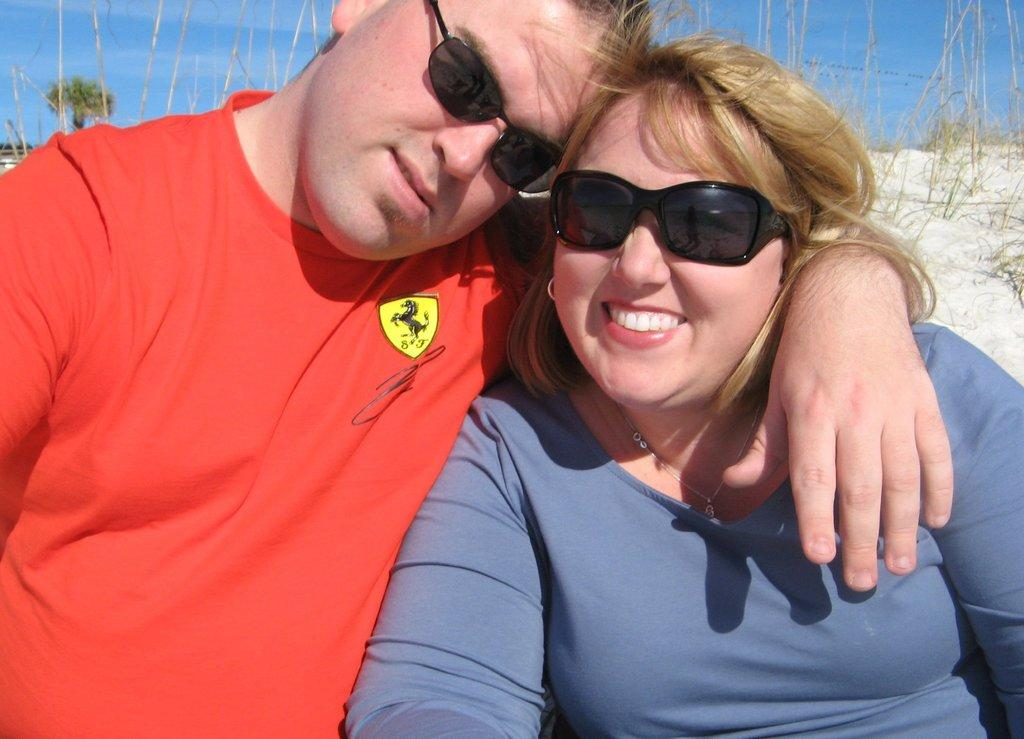Who are the people in the image? There is a man and a lady in the image. What can be seen in the background of the image? There is a tree and plants in the image. What type of terrain is visible in the image? There is sand in the image. What sign is the man holding in the image? There is no sign present in the image; the man is not holding anything. 